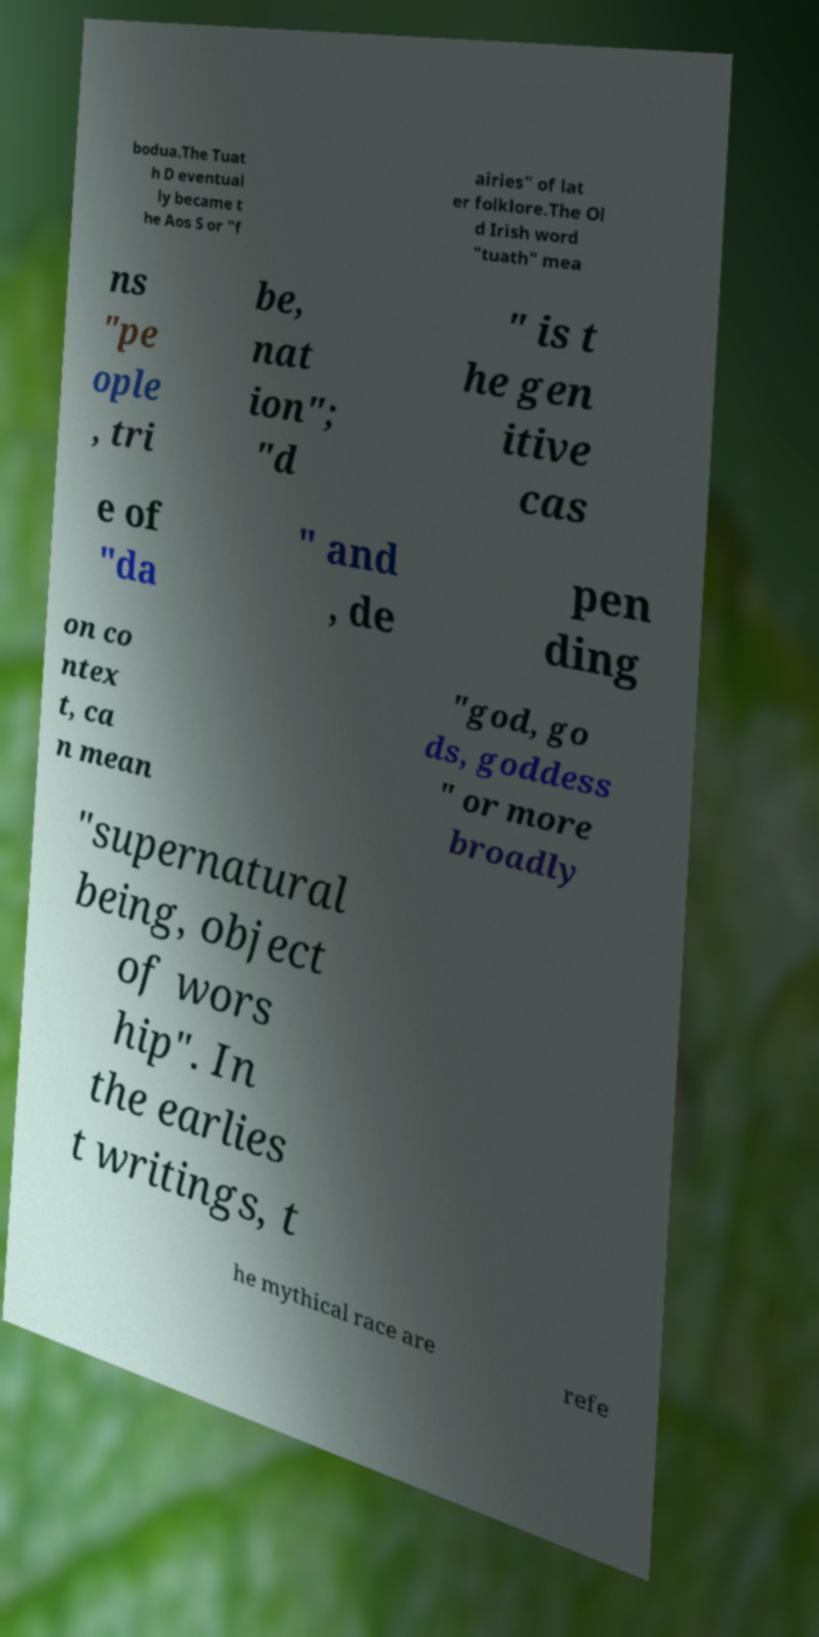Please read and relay the text visible in this image. What does it say? bodua.The Tuat h D eventual ly became t he Aos S or "f airies" of lat er folklore.The Ol d Irish word "tuath" mea ns "pe ople , tri be, nat ion"; "d " is t he gen itive cas e of "da " and , de pen ding on co ntex t, ca n mean "god, go ds, goddess " or more broadly "supernatural being, object of wors hip". In the earlies t writings, t he mythical race are refe 